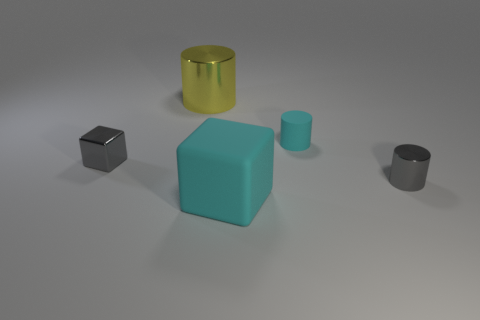There is a shiny object that is the same color as the small block; what is its size?
Provide a succinct answer. Small. How many large things are the same color as the tiny matte object?
Provide a succinct answer. 1. Is the number of tiny matte cylinders that are behind the tiny gray metal cube greater than the number of gray shiny objects in front of the large cyan matte thing?
Ensure brevity in your answer.  Yes. What material is the cylinder that is to the left of the gray cylinder and in front of the big yellow thing?
Give a very brief answer. Rubber. Does the yellow metallic thing have the same shape as the big cyan rubber thing?
Make the answer very short. No. Is there any other thing that is the same size as the cyan matte cylinder?
Give a very brief answer. Yes. There is a tiny block; how many big cubes are behind it?
Keep it short and to the point. 0. Do the gray metallic object that is on the right side of the shiny block and the matte cylinder have the same size?
Ensure brevity in your answer.  Yes. There is a metallic thing that is the same shape as the big cyan rubber thing; what is its color?
Provide a succinct answer. Gray. Are there any other things that are the same shape as the big cyan rubber object?
Provide a succinct answer. Yes. 